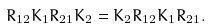<formula> <loc_0><loc_0><loc_500><loc_500>R _ { 1 2 } K _ { 1 } R _ { 2 1 } K _ { 2 } = K _ { 2 } R _ { 1 2 } K _ { 1 } R _ { 2 1 } .</formula> 